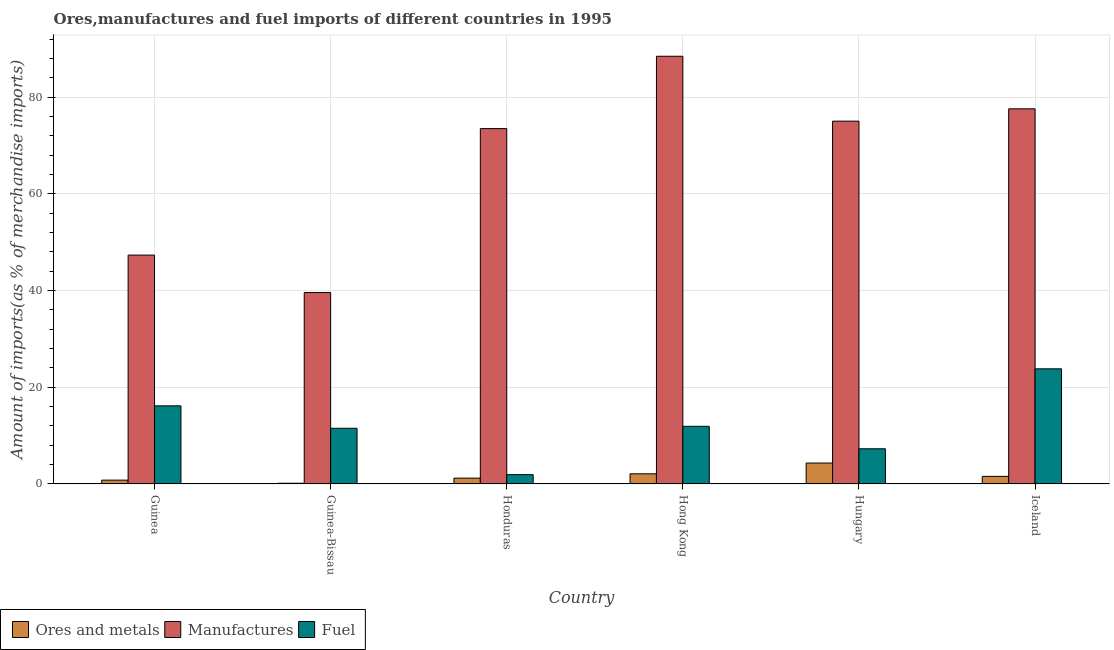How many different coloured bars are there?
Your response must be concise. 3. How many groups of bars are there?
Give a very brief answer. 6. Are the number of bars on each tick of the X-axis equal?
Give a very brief answer. Yes. What is the percentage of manufactures imports in Guinea-Bissau?
Give a very brief answer. 39.6. Across all countries, what is the maximum percentage of manufactures imports?
Your answer should be compact. 88.48. Across all countries, what is the minimum percentage of ores and metals imports?
Make the answer very short. 0.15. In which country was the percentage of ores and metals imports maximum?
Keep it short and to the point. Hungary. In which country was the percentage of manufactures imports minimum?
Offer a terse response. Guinea-Bissau. What is the total percentage of ores and metals imports in the graph?
Give a very brief answer. 10.16. What is the difference between the percentage of fuel imports in Honduras and that in Iceland?
Ensure brevity in your answer.  -21.89. What is the difference between the percentage of fuel imports in Iceland and the percentage of ores and metals imports in Honduras?
Your answer should be compact. 22.61. What is the average percentage of manufactures imports per country?
Ensure brevity in your answer.  66.93. What is the difference between the percentage of manufactures imports and percentage of ores and metals imports in Guinea?
Provide a succinct answer. 46.55. In how many countries, is the percentage of ores and metals imports greater than 24 %?
Offer a terse response. 0. What is the ratio of the percentage of fuel imports in Guinea to that in Hungary?
Provide a short and direct response. 2.22. Is the percentage of ores and metals imports in Guinea less than that in Hungary?
Make the answer very short. Yes. What is the difference between the highest and the second highest percentage of manufactures imports?
Your answer should be compact. 10.87. What is the difference between the highest and the lowest percentage of manufactures imports?
Keep it short and to the point. 48.88. In how many countries, is the percentage of fuel imports greater than the average percentage of fuel imports taken over all countries?
Your response must be concise. 2. Is the sum of the percentage of ores and metals imports in Guinea-Bissau and Hungary greater than the maximum percentage of manufactures imports across all countries?
Your answer should be compact. No. What does the 1st bar from the left in Guinea-Bissau represents?
Offer a terse response. Ores and metals. What does the 1st bar from the right in Guinea represents?
Provide a short and direct response. Fuel. Does the graph contain grids?
Give a very brief answer. Yes. How are the legend labels stacked?
Give a very brief answer. Horizontal. What is the title of the graph?
Give a very brief answer. Ores,manufactures and fuel imports of different countries in 1995. Does "Travel services" appear as one of the legend labels in the graph?
Give a very brief answer. No. What is the label or title of the Y-axis?
Give a very brief answer. Amount of imports(as % of merchandise imports). What is the Amount of imports(as % of merchandise imports) in Ores and metals in Guinea?
Give a very brief answer. 0.8. What is the Amount of imports(as % of merchandise imports) of Manufactures in Guinea?
Make the answer very short. 47.35. What is the Amount of imports(as % of merchandise imports) in Fuel in Guinea?
Offer a terse response. 16.16. What is the Amount of imports(as % of merchandise imports) of Ores and metals in Guinea-Bissau?
Offer a terse response. 0.15. What is the Amount of imports(as % of merchandise imports) in Manufactures in Guinea-Bissau?
Offer a very short reply. 39.6. What is the Amount of imports(as % of merchandise imports) in Fuel in Guinea-Bissau?
Offer a terse response. 11.52. What is the Amount of imports(as % of merchandise imports) in Ores and metals in Honduras?
Make the answer very short. 1.21. What is the Amount of imports(as % of merchandise imports) in Manufactures in Honduras?
Offer a very short reply. 73.51. What is the Amount of imports(as % of merchandise imports) in Fuel in Honduras?
Ensure brevity in your answer.  1.93. What is the Amount of imports(as % of merchandise imports) in Ores and metals in Hong Kong?
Give a very brief answer. 2.1. What is the Amount of imports(as % of merchandise imports) in Manufactures in Hong Kong?
Your answer should be compact. 88.48. What is the Amount of imports(as % of merchandise imports) of Fuel in Hong Kong?
Keep it short and to the point. 11.93. What is the Amount of imports(as % of merchandise imports) in Ores and metals in Hungary?
Your response must be concise. 4.33. What is the Amount of imports(as % of merchandise imports) in Manufactures in Hungary?
Give a very brief answer. 75.06. What is the Amount of imports(as % of merchandise imports) in Fuel in Hungary?
Provide a short and direct response. 7.28. What is the Amount of imports(as % of merchandise imports) in Ores and metals in Iceland?
Provide a short and direct response. 1.57. What is the Amount of imports(as % of merchandise imports) of Manufactures in Iceland?
Your response must be concise. 77.6. What is the Amount of imports(as % of merchandise imports) of Fuel in Iceland?
Make the answer very short. 23.82. Across all countries, what is the maximum Amount of imports(as % of merchandise imports) in Ores and metals?
Offer a very short reply. 4.33. Across all countries, what is the maximum Amount of imports(as % of merchandise imports) of Manufactures?
Provide a short and direct response. 88.48. Across all countries, what is the maximum Amount of imports(as % of merchandise imports) in Fuel?
Your answer should be compact. 23.82. Across all countries, what is the minimum Amount of imports(as % of merchandise imports) in Ores and metals?
Your response must be concise. 0.15. Across all countries, what is the minimum Amount of imports(as % of merchandise imports) in Manufactures?
Your answer should be very brief. 39.6. Across all countries, what is the minimum Amount of imports(as % of merchandise imports) of Fuel?
Your response must be concise. 1.93. What is the total Amount of imports(as % of merchandise imports) in Ores and metals in the graph?
Offer a terse response. 10.16. What is the total Amount of imports(as % of merchandise imports) of Manufactures in the graph?
Your response must be concise. 401.6. What is the total Amount of imports(as % of merchandise imports) of Fuel in the graph?
Ensure brevity in your answer.  72.64. What is the difference between the Amount of imports(as % of merchandise imports) of Ores and metals in Guinea and that in Guinea-Bissau?
Offer a terse response. 0.64. What is the difference between the Amount of imports(as % of merchandise imports) of Manufactures in Guinea and that in Guinea-Bissau?
Offer a very short reply. 7.75. What is the difference between the Amount of imports(as % of merchandise imports) in Fuel in Guinea and that in Guinea-Bissau?
Your answer should be very brief. 4.64. What is the difference between the Amount of imports(as % of merchandise imports) in Ores and metals in Guinea and that in Honduras?
Your answer should be compact. -0.42. What is the difference between the Amount of imports(as % of merchandise imports) in Manufactures in Guinea and that in Honduras?
Make the answer very short. -26.16. What is the difference between the Amount of imports(as % of merchandise imports) in Fuel in Guinea and that in Honduras?
Offer a terse response. 14.23. What is the difference between the Amount of imports(as % of merchandise imports) of Ores and metals in Guinea and that in Hong Kong?
Provide a succinct answer. -1.31. What is the difference between the Amount of imports(as % of merchandise imports) of Manufactures in Guinea and that in Hong Kong?
Provide a succinct answer. -41.13. What is the difference between the Amount of imports(as % of merchandise imports) in Fuel in Guinea and that in Hong Kong?
Make the answer very short. 4.23. What is the difference between the Amount of imports(as % of merchandise imports) in Ores and metals in Guinea and that in Hungary?
Your response must be concise. -3.53. What is the difference between the Amount of imports(as % of merchandise imports) in Manufactures in Guinea and that in Hungary?
Provide a short and direct response. -27.71. What is the difference between the Amount of imports(as % of merchandise imports) of Fuel in Guinea and that in Hungary?
Your answer should be compact. 8.88. What is the difference between the Amount of imports(as % of merchandise imports) in Ores and metals in Guinea and that in Iceland?
Your response must be concise. -0.77. What is the difference between the Amount of imports(as % of merchandise imports) in Manufactures in Guinea and that in Iceland?
Give a very brief answer. -30.26. What is the difference between the Amount of imports(as % of merchandise imports) in Fuel in Guinea and that in Iceland?
Your answer should be compact. -7.66. What is the difference between the Amount of imports(as % of merchandise imports) of Ores and metals in Guinea-Bissau and that in Honduras?
Ensure brevity in your answer.  -1.06. What is the difference between the Amount of imports(as % of merchandise imports) of Manufactures in Guinea-Bissau and that in Honduras?
Your answer should be compact. -33.91. What is the difference between the Amount of imports(as % of merchandise imports) in Fuel in Guinea-Bissau and that in Honduras?
Provide a short and direct response. 9.59. What is the difference between the Amount of imports(as % of merchandise imports) of Ores and metals in Guinea-Bissau and that in Hong Kong?
Provide a short and direct response. -1.95. What is the difference between the Amount of imports(as % of merchandise imports) in Manufactures in Guinea-Bissau and that in Hong Kong?
Provide a succinct answer. -48.88. What is the difference between the Amount of imports(as % of merchandise imports) in Fuel in Guinea-Bissau and that in Hong Kong?
Make the answer very short. -0.41. What is the difference between the Amount of imports(as % of merchandise imports) of Ores and metals in Guinea-Bissau and that in Hungary?
Ensure brevity in your answer.  -4.18. What is the difference between the Amount of imports(as % of merchandise imports) in Manufactures in Guinea-Bissau and that in Hungary?
Give a very brief answer. -35.45. What is the difference between the Amount of imports(as % of merchandise imports) in Fuel in Guinea-Bissau and that in Hungary?
Make the answer very short. 4.24. What is the difference between the Amount of imports(as % of merchandise imports) of Ores and metals in Guinea-Bissau and that in Iceland?
Ensure brevity in your answer.  -1.42. What is the difference between the Amount of imports(as % of merchandise imports) in Manufactures in Guinea-Bissau and that in Iceland?
Ensure brevity in your answer.  -38. What is the difference between the Amount of imports(as % of merchandise imports) in Fuel in Guinea-Bissau and that in Iceland?
Offer a very short reply. -12.3. What is the difference between the Amount of imports(as % of merchandise imports) in Ores and metals in Honduras and that in Hong Kong?
Give a very brief answer. -0.89. What is the difference between the Amount of imports(as % of merchandise imports) of Manufactures in Honduras and that in Hong Kong?
Offer a terse response. -14.97. What is the difference between the Amount of imports(as % of merchandise imports) of Fuel in Honduras and that in Hong Kong?
Offer a terse response. -10. What is the difference between the Amount of imports(as % of merchandise imports) of Ores and metals in Honduras and that in Hungary?
Provide a short and direct response. -3.12. What is the difference between the Amount of imports(as % of merchandise imports) of Manufactures in Honduras and that in Hungary?
Make the answer very short. -1.55. What is the difference between the Amount of imports(as % of merchandise imports) of Fuel in Honduras and that in Hungary?
Your response must be concise. -5.35. What is the difference between the Amount of imports(as % of merchandise imports) in Ores and metals in Honduras and that in Iceland?
Offer a terse response. -0.36. What is the difference between the Amount of imports(as % of merchandise imports) of Manufactures in Honduras and that in Iceland?
Your answer should be very brief. -4.09. What is the difference between the Amount of imports(as % of merchandise imports) in Fuel in Honduras and that in Iceland?
Give a very brief answer. -21.89. What is the difference between the Amount of imports(as % of merchandise imports) in Ores and metals in Hong Kong and that in Hungary?
Provide a succinct answer. -2.22. What is the difference between the Amount of imports(as % of merchandise imports) of Manufactures in Hong Kong and that in Hungary?
Offer a very short reply. 13.42. What is the difference between the Amount of imports(as % of merchandise imports) of Fuel in Hong Kong and that in Hungary?
Provide a succinct answer. 4.65. What is the difference between the Amount of imports(as % of merchandise imports) in Ores and metals in Hong Kong and that in Iceland?
Your answer should be compact. 0.53. What is the difference between the Amount of imports(as % of merchandise imports) of Manufactures in Hong Kong and that in Iceland?
Give a very brief answer. 10.87. What is the difference between the Amount of imports(as % of merchandise imports) of Fuel in Hong Kong and that in Iceland?
Ensure brevity in your answer.  -11.89. What is the difference between the Amount of imports(as % of merchandise imports) of Ores and metals in Hungary and that in Iceland?
Offer a very short reply. 2.76. What is the difference between the Amount of imports(as % of merchandise imports) of Manufactures in Hungary and that in Iceland?
Provide a succinct answer. -2.55. What is the difference between the Amount of imports(as % of merchandise imports) of Fuel in Hungary and that in Iceland?
Make the answer very short. -16.54. What is the difference between the Amount of imports(as % of merchandise imports) in Ores and metals in Guinea and the Amount of imports(as % of merchandise imports) in Manufactures in Guinea-Bissau?
Your answer should be compact. -38.81. What is the difference between the Amount of imports(as % of merchandise imports) in Ores and metals in Guinea and the Amount of imports(as % of merchandise imports) in Fuel in Guinea-Bissau?
Provide a succinct answer. -10.73. What is the difference between the Amount of imports(as % of merchandise imports) of Manufactures in Guinea and the Amount of imports(as % of merchandise imports) of Fuel in Guinea-Bissau?
Ensure brevity in your answer.  35.83. What is the difference between the Amount of imports(as % of merchandise imports) in Ores and metals in Guinea and the Amount of imports(as % of merchandise imports) in Manufactures in Honduras?
Your response must be concise. -72.71. What is the difference between the Amount of imports(as % of merchandise imports) of Ores and metals in Guinea and the Amount of imports(as % of merchandise imports) of Fuel in Honduras?
Keep it short and to the point. -1.13. What is the difference between the Amount of imports(as % of merchandise imports) of Manufactures in Guinea and the Amount of imports(as % of merchandise imports) of Fuel in Honduras?
Provide a short and direct response. 45.42. What is the difference between the Amount of imports(as % of merchandise imports) of Ores and metals in Guinea and the Amount of imports(as % of merchandise imports) of Manufactures in Hong Kong?
Your answer should be compact. -87.68. What is the difference between the Amount of imports(as % of merchandise imports) of Ores and metals in Guinea and the Amount of imports(as % of merchandise imports) of Fuel in Hong Kong?
Offer a terse response. -11.13. What is the difference between the Amount of imports(as % of merchandise imports) in Manufactures in Guinea and the Amount of imports(as % of merchandise imports) in Fuel in Hong Kong?
Offer a terse response. 35.42. What is the difference between the Amount of imports(as % of merchandise imports) in Ores and metals in Guinea and the Amount of imports(as % of merchandise imports) in Manufactures in Hungary?
Your response must be concise. -74.26. What is the difference between the Amount of imports(as % of merchandise imports) in Ores and metals in Guinea and the Amount of imports(as % of merchandise imports) in Fuel in Hungary?
Make the answer very short. -6.49. What is the difference between the Amount of imports(as % of merchandise imports) in Manufactures in Guinea and the Amount of imports(as % of merchandise imports) in Fuel in Hungary?
Give a very brief answer. 40.07. What is the difference between the Amount of imports(as % of merchandise imports) in Ores and metals in Guinea and the Amount of imports(as % of merchandise imports) in Manufactures in Iceland?
Offer a very short reply. -76.81. What is the difference between the Amount of imports(as % of merchandise imports) of Ores and metals in Guinea and the Amount of imports(as % of merchandise imports) of Fuel in Iceland?
Offer a terse response. -23.03. What is the difference between the Amount of imports(as % of merchandise imports) of Manufactures in Guinea and the Amount of imports(as % of merchandise imports) of Fuel in Iceland?
Your answer should be very brief. 23.53. What is the difference between the Amount of imports(as % of merchandise imports) in Ores and metals in Guinea-Bissau and the Amount of imports(as % of merchandise imports) in Manufactures in Honduras?
Your answer should be very brief. -73.36. What is the difference between the Amount of imports(as % of merchandise imports) in Ores and metals in Guinea-Bissau and the Amount of imports(as % of merchandise imports) in Fuel in Honduras?
Your answer should be compact. -1.78. What is the difference between the Amount of imports(as % of merchandise imports) in Manufactures in Guinea-Bissau and the Amount of imports(as % of merchandise imports) in Fuel in Honduras?
Provide a succinct answer. 37.67. What is the difference between the Amount of imports(as % of merchandise imports) of Ores and metals in Guinea-Bissau and the Amount of imports(as % of merchandise imports) of Manufactures in Hong Kong?
Ensure brevity in your answer.  -88.33. What is the difference between the Amount of imports(as % of merchandise imports) of Ores and metals in Guinea-Bissau and the Amount of imports(as % of merchandise imports) of Fuel in Hong Kong?
Ensure brevity in your answer.  -11.78. What is the difference between the Amount of imports(as % of merchandise imports) in Manufactures in Guinea-Bissau and the Amount of imports(as % of merchandise imports) in Fuel in Hong Kong?
Ensure brevity in your answer.  27.67. What is the difference between the Amount of imports(as % of merchandise imports) of Ores and metals in Guinea-Bissau and the Amount of imports(as % of merchandise imports) of Manufactures in Hungary?
Offer a terse response. -74.9. What is the difference between the Amount of imports(as % of merchandise imports) of Ores and metals in Guinea-Bissau and the Amount of imports(as % of merchandise imports) of Fuel in Hungary?
Keep it short and to the point. -7.13. What is the difference between the Amount of imports(as % of merchandise imports) in Manufactures in Guinea-Bissau and the Amount of imports(as % of merchandise imports) in Fuel in Hungary?
Keep it short and to the point. 32.32. What is the difference between the Amount of imports(as % of merchandise imports) of Ores and metals in Guinea-Bissau and the Amount of imports(as % of merchandise imports) of Manufactures in Iceland?
Your response must be concise. -77.45. What is the difference between the Amount of imports(as % of merchandise imports) of Ores and metals in Guinea-Bissau and the Amount of imports(as % of merchandise imports) of Fuel in Iceland?
Your response must be concise. -23.67. What is the difference between the Amount of imports(as % of merchandise imports) in Manufactures in Guinea-Bissau and the Amount of imports(as % of merchandise imports) in Fuel in Iceland?
Offer a terse response. 15.78. What is the difference between the Amount of imports(as % of merchandise imports) in Ores and metals in Honduras and the Amount of imports(as % of merchandise imports) in Manufactures in Hong Kong?
Your answer should be very brief. -87.27. What is the difference between the Amount of imports(as % of merchandise imports) in Ores and metals in Honduras and the Amount of imports(as % of merchandise imports) in Fuel in Hong Kong?
Ensure brevity in your answer.  -10.72. What is the difference between the Amount of imports(as % of merchandise imports) in Manufactures in Honduras and the Amount of imports(as % of merchandise imports) in Fuel in Hong Kong?
Offer a terse response. 61.58. What is the difference between the Amount of imports(as % of merchandise imports) in Ores and metals in Honduras and the Amount of imports(as % of merchandise imports) in Manufactures in Hungary?
Keep it short and to the point. -73.84. What is the difference between the Amount of imports(as % of merchandise imports) in Ores and metals in Honduras and the Amount of imports(as % of merchandise imports) in Fuel in Hungary?
Your answer should be compact. -6.07. What is the difference between the Amount of imports(as % of merchandise imports) in Manufactures in Honduras and the Amount of imports(as % of merchandise imports) in Fuel in Hungary?
Offer a very short reply. 66.23. What is the difference between the Amount of imports(as % of merchandise imports) of Ores and metals in Honduras and the Amount of imports(as % of merchandise imports) of Manufactures in Iceland?
Your answer should be compact. -76.39. What is the difference between the Amount of imports(as % of merchandise imports) of Ores and metals in Honduras and the Amount of imports(as % of merchandise imports) of Fuel in Iceland?
Provide a succinct answer. -22.61. What is the difference between the Amount of imports(as % of merchandise imports) in Manufactures in Honduras and the Amount of imports(as % of merchandise imports) in Fuel in Iceland?
Offer a terse response. 49.69. What is the difference between the Amount of imports(as % of merchandise imports) of Ores and metals in Hong Kong and the Amount of imports(as % of merchandise imports) of Manufactures in Hungary?
Provide a short and direct response. -72.95. What is the difference between the Amount of imports(as % of merchandise imports) in Ores and metals in Hong Kong and the Amount of imports(as % of merchandise imports) in Fuel in Hungary?
Offer a very short reply. -5.18. What is the difference between the Amount of imports(as % of merchandise imports) of Manufactures in Hong Kong and the Amount of imports(as % of merchandise imports) of Fuel in Hungary?
Keep it short and to the point. 81.2. What is the difference between the Amount of imports(as % of merchandise imports) in Ores and metals in Hong Kong and the Amount of imports(as % of merchandise imports) in Manufactures in Iceland?
Offer a terse response. -75.5. What is the difference between the Amount of imports(as % of merchandise imports) of Ores and metals in Hong Kong and the Amount of imports(as % of merchandise imports) of Fuel in Iceland?
Keep it short and to the point. -21.72. What is the difference between the Amount of imports(as % of merchandise imports) of Manufactures in Hong Kong and the Amount of imports(as % of merchandise imports) of Fuel in Iceland?
Keep it short and to the point. 64.66. What is the difference between the Amount of imports(as % of merchandise imports) of Ores and metals in Hungary and the Amount of imports(as % of merchandise imports) of Manufactures in Iceland?
Provide a short and direct response. -73.28. What is the difference between the Amount of imports(as % of merchandise imports) in Ores and metals in Hungary and the Amount of imports(as % of merchandise imports) in Fuel in Iceland?
Keep it short and to the point. -19.49. What is the difference between the Amount of imports(as % of merchandise imports) in Manufactures in Hungary and the Amount of imports(as % of merchandise imports) in Fuel in Iceland?
Give a very brief answer. 51.23. What is the average Amount of imports(as % of merchandise imports) of Ores and metals per country?
Make the answer very short. 1.69. What is the average Amount of imports(as % of merchandise imports) of Manufactures per country?
Provide a short and direct response. 66.93. What is the average Amount of imports(as % of merchandise imports) in Fuel per country?
Your answer should be very brief. 12.11. What is the difference between the Amount of imports(as % of merchandise imports) of Ores and metals and Amount of imports(as % of merchandise imports) of Manufactures in Guinea?
Your answer should be very brief. -46.55. What is the difference between the Amount of imports(as % of merchandise imports) in Ores and metals and Amount of imports(as % of merchandise imports) in Fuel in Guinea?
Your answer should be compact. -15.37. What is the difference between the Amount of imports(as % of merchandise imports) in Manufactures and Amount of imports(as % of merchandise imports) in Fuel in Guinea?
Offer a terse response. 31.19. What is the difference between the Amount of imports(as % of merchandise imports) in Ores and metals and Amount of imports(as % of merchandise imports) in Manufactures in Guinea-Bissau?
Offer a very short reply. -39.45. What is the difference between the Amount of imports(as % of merchandise imports) in Ores and metals and Amount of imports(as % of merchandise imports) in Fuel in Guinea-Bissau?
Your answer should be very brief. -11.37. What is the difference between the Amount of imports(as % of merchandise imports) in Manufactures and Amount of imports(as % of merchandise imports) in Fuel in Guinea-Bissau?
Keep it short and to the point. 28.08. What is the difference between the Amount of imports(as % of merchandise imports) in Ores and metals and Amount of imports(as % of merchandise imports) in Manufactures in Honduras?
Keep it short and to the point. -72.3. What is the difference between the Amount of imports(as % of merchandise imports) of Ores and metals and Amount of imports(as % of merchandise imports) of Fuel in Honduras?
Offer a terse response. -0.72. What is the difference between the Amount of imports(as % of merchandise imports) of Manufactures and Amount of imports(as % of merchandise imports) of Fuel in Honduras?
Make the answer very short. 71.58. What is the difference between the Amount of imports(as % of merchandise imports) of Ores and metals and Amount of imports(as % of merchandise imports) of Manufactures in Hong Kong?
Offer a very short reply. -86.37. What is the difference between the Amount of imports(as % of merchandise imports) of Ores and metals and Amount of imports(as % of merchandise imports) of Fuel in Hong Kong?
Provide a short and direct response. -9.82. What is the difference between the Amount of imports(as % of merchandise imports) of Manufactures and Amount of imports(as % of merchandise imports) of Fuel in Hong Kong?
Give a very brief answer. 76.55. What is the difference between the Amount of imports(as % of merchandise imports) in Ores and metals and Amount of imports(as % of merchandise imports) in Manufactures in Hungary?
Offer a terse response. -70.73. What is the difference between the Amount of imports(as % of merchandise imports) of Ores and metals and Amount of imports(as % of merchandise imports) of Fuel in Hungary?
Give a very brief answer. -2.95. What is the difference between the Amount of imports(as % of merchandise imports) of Manufactures and Amount of imports(as % of merchandise imports) of Fuel in Hungary?
Your answer should be very brief. 67.78. What is the difference between the Amount of imports(as % of merchandise imports) in Ores and metals and Amount of imports(as % of merchandise imports) in Manufactures in Iceland?
Your answer should be very brief. -76.03. What is the difference between the Amount of imports(as % of merchandise imports) of Ores and metals and Amount of imports(as % of merchandise imports) of Fuel in Iceland?
Ensure brevity in your answer.  -22.25. What is the difference between the Amount of imports(as % of merchandise imports) of Manufactures and Amount of imports(as % of merchandise imports) of Fuel in Iceland?
Give a very brief answer. 53.78. What is the ratio of the Amount of imports(as % of merchandise imports) in Ores and metals in Guinea to that in Guinea-Bissau?
Make the answer very short. 5.25. What is the ratio of the Amount of imports(as % of merchandise imports) in Manufactures in Guinea to that in Guinea-Bissau?
Offer a terse response. 1.2. What is the ratio of the Amount of imports(as % of merchandise imports) in Fuel in Guinea to that in Guinea-Bissau?
Your answer should be compact. 1.4. What is the ratio of the Amount of imports(as % of merchandise imports) of Ores and metals in Guinea to that in Honduras?
Your response must be concise. 0.66. What is the ratio of the Amount of imports(as % of merchandise imports) of Manufactures in Guinea to that in Honduras?
Give a very brief answer. 0.64. What is the ratio of the Amount of imports(as % of merchandise imports) of Fuel in Guinea to that in Honduras?
Provide a succinct answer. 8.38. What is the ratio of the Amount of imports(as % of merchandise imports) of Ores and metals in Guinea to that in Hong Kong?
Provide a short and direct response. 0.38. What is the ratio of the Amount of imports(as % of merchandise imports) of Manufactures in Guinea to that in Hong Kong?
Offer a very short reply. 0.54. What is the ratio of the Amount of imports(as % of merchandise imports) in Fuel in Guinea to that in Hong Kong?
Ensure brevity in your answer.  1.35. What is the ratio of the Amount of imports(as % of merchandise imports) of Ores and metals in Guinea to that in Hungary?
Offer a very short reply. 0.18. What is the ratio of the Amount of imports(as % of merchandise imports) of Manufactures in Guinea to that in Hungary?
Make the answer very short. 0.63. What is the ratio of the Amount of imports(as % of merchandise imports) in Fuel in Guinea to that in Hungary?
Your response must be concise. 2.22. What is the ratio of the Amount of imports(as % of merchandise imports) of Ores and metals in Guinea to that in Iceland?
Offer a terse response. 0.51. What is the ratio of the Amount of imports(as % of merchandise imports) in Manufactures in Guinea to that in Iceland?
Provide a succinct answer. 0.61. What is the ratio of the Amount of imports(as % of merchandise imports) in Fuel in Guinea to that in Iceland?
Ensure brevity in your answer.  0.68. What is the ratio of the Amount of imports(as % of merchandise imports) of Ores and metals in Guinea-Bissau to that in Honduras?
Offer a very short reply. 0.13. What is the ratio of the Amount of imports(as % of merchandise imports) in Manufactures in Guinea-Bissau to that in Honduras?
Provide a succinct answer. 0.54. What is the ratio of the Amount of imports(as % of merchandise imports) in Fuel in Guinea-Bissau to that in Honduras?
Provide a succinct answer. 5.97. What is the ratio of the Amount of imports(as % of merchandise imports) of Ores and metals in Guinea-Bissau to that in Hong Kong?
Offer a terse response. 0.07. What is the ratio of the Amount of imports(as % of merchandise imports) of Manufactures in Guinea-Bissau to that in Hong Kong?
Give a very brief answer. 0.45. What is the ratio of the Amount of imports(as % of merchandise imports) in Ores and metals in Guinea-Bissau to that in Hungary?
Give a very brief answer. 0.04. What is the ratio of the Amount of imports(as % of merchandise imports) of Manufactures in Guinea-Bissau to that in Hungary?
Make the answer very short. 0.53. What is the ratio of the Amount of imports(as % of merchandise imports) of Fuel in Guinea-Bissau to that in Hungary?
Give a very brief answer. 1.58. What is the ratio of the Amount of imports(as % of merchandise imports) of Ores and metals in Guinea-Bissau to that in Iceland?
Give a very brief answer. 0.1. What is the ratio of the Amount of imports(as % of merchandise imports) in Manufactures in Guinea-Bissau to that in Iceland?
Make the answer very short. 0.51. What is the ratio of the Amount of imports(as % of merchandise imports) of Fuel in Guinea-Bissau to that in Iceland?
Make the answer very short. 0.48. What is the ratio of the Amount of imports(as % of merchandise imports) of Ores and metals in Honduras to that in Hong Kong?
Keep it short and to the point. 0.58. What is the ratio of the Amount of imports(as % of merchandise imports) of Manufactures in Honduras to that in Hong Kong?
Provide a succinct answer. 0.83. What is the ratio of the Amount of imports(as % of merchandise imports) of Fuel in Honduras to that in Hong Kong?
Keep it short and to the point. 0.16. What is the ratio of the Amount of imports(as % of merchandise imports) in Ores and metals in Honduras to that in Hungary?
Offer a very short reply. 0.28. What is the ratio of the Amount of imports(as % of merchandise imports) in Manufactures in Honduras to that in Hungary?
Your response must be concise. 0.98. What is the ratio of the Amount of imports(as % of merchandise imports) in Fuel in Honduras to that in Hungary?
Keep it short and to the point. 0.26. What is the ratio of the Amount of imports(as % of merchandise imports) in Ores and metals in Honduras to that in Iceland?
Provide a succinct answer. 0.77. What is the ratio of the Amount of imports(as % of merchandise imports) in Manufactures in Honduras to that in Iceland?
Provide a short and direct response. 0.95. What is the ratio of the Amount of imports(as % of merchandise imports) of Fuel in Honduras to that in Iceland?
Offer a terse response. 0.08. What is the ratio of the Amount of imports(as % of merchandise imports) in Ores and metals in Hong Kong to that in Hungary?
Provide a short and direct response. 0.49. What is the ratio of the Amount of imports(as % of merchandise imports) in Manufactures in Hong Kong to that in Hungary?
Your response must be concise. 1.18. What is the ratio of the Amount of imports(as % of merchandise imports) of Fuel in Hong Kong to that in Hungary?
Ensure brevity in your answer.  1.64. What is the ratio of the Amount of imports(as % of merchandise imports) of Ores and metals in Hong Kong to that in Iceland?
Give a very brief answer. 1.34. What is the ratio of the Amount of imports(as % of merchandise imports) of Manufactures in Hong Kong to that in Iceland?
Provide a succinct answer. 1.14. What is the ratio of the Amount of imports(as % of merchandise imports) in Fuel in Hong Kong to that in Iceland?
Your answer should be compact. 0.5. What is the ratio of the Amount of imports(as % of merchandise imports) in Ores and metals in Hungary to that in Iceland?
Your answer should be compact. 2.76. What is the ratio of the Amount of imports(as % of merchandise imports) of Manufactures in Hungary to that in Iceland?
Offer a very short reply. 0.97. What is the ratio of the Amount of imports(as % of merchandise imports) in Fuel in Hungary to that in Iceland?
Give a very brief answer. 0.31. What is the difference between the highest and the second highest Amount of imports(as % of merchandise imports) of Ores and metals?
Make the answer very short. 2.22. What is the difference between the highest and the second highest Amount of imports(as % of merchandise imports) of Manufactures?
Offer a very short reply. 10.87. What is the difference between the highest and the second highest Amount of imports(as % of merchandise imports) in Fuel?
Your response must be concise. 7.66. What is the difference between the highest and the lowest Amount of imports(as % of merchandise imports) of Ores and metals?
Give a very brief answer. 4.18. What is the difference between the highest and the lowest Amount of imports(as % of merchandise imports) of Manufactures?
Your answer should be very brief. 48.88. What is the difference between the highest and the lowest Amount of imports(as % of merchandise imports) in Fuel?
Provide a short and direct response. 21.89. 